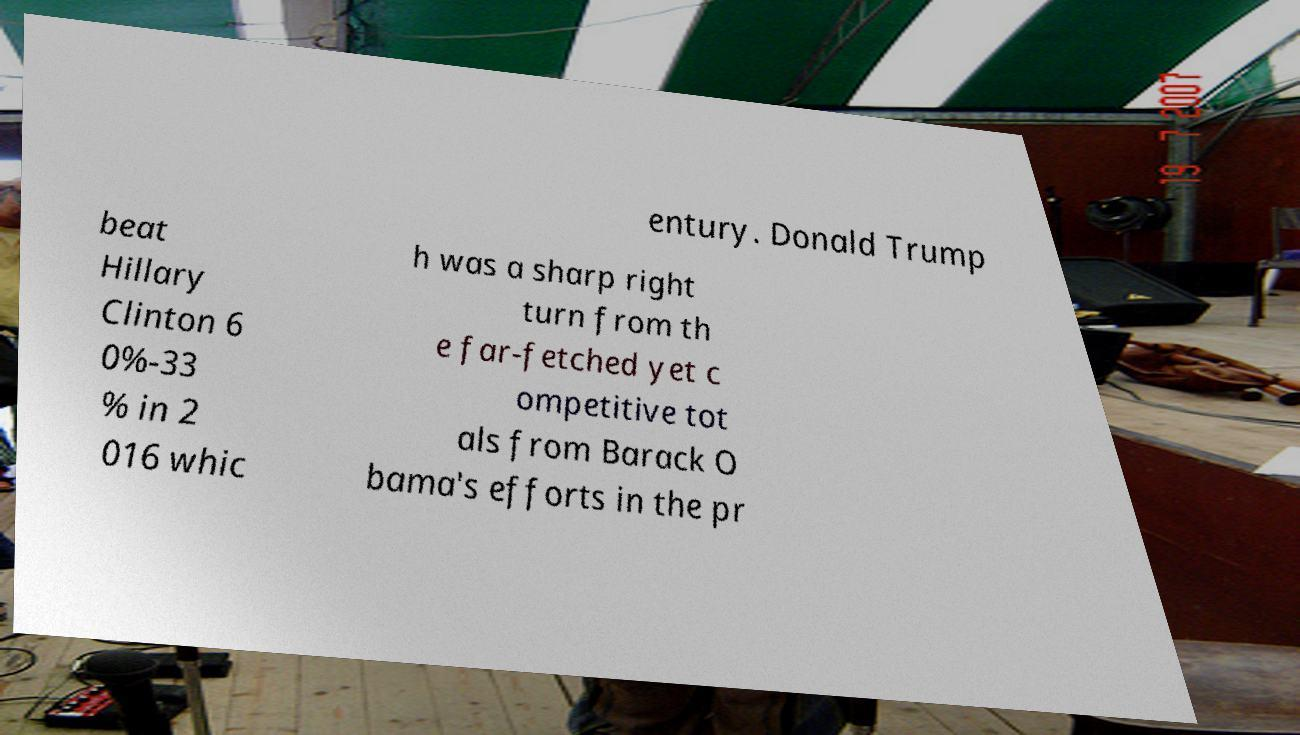Could you assist in decoding the text presented in this image and type it out clearly? entury. Donald Trump beat Hillary Clinton 6 0%-33 % in 2 016 whic h was a sharp right turn from th e far-fetched yet c ompetitive tot als from Barack O bama's efforts in the pr 